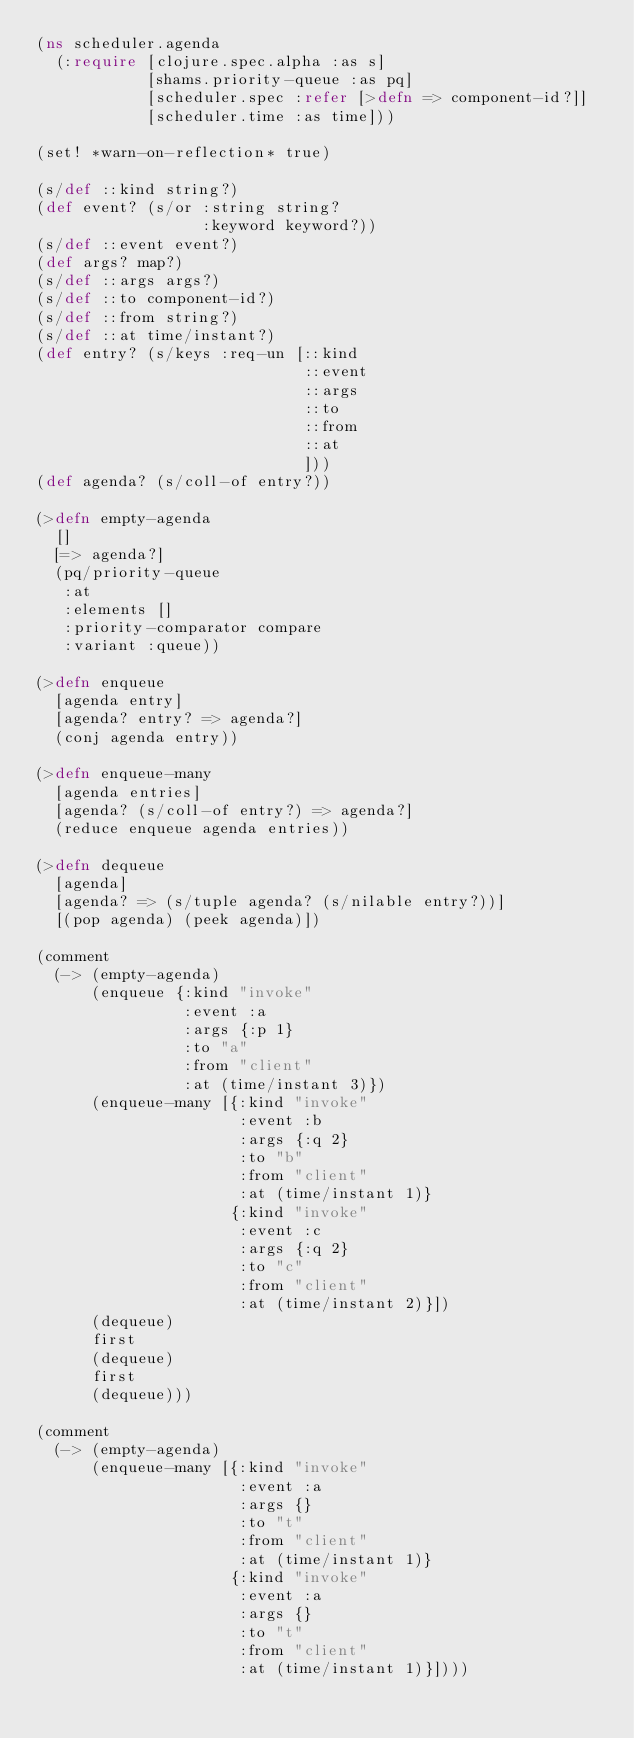Convert code to text. <code><loc_0><loc_0><loc_500><loc_500><_Clojure_>(ns scheduler.agenda
  (:require [clojure.spec.alpha :as s]
            [shams.priority-queue :as pq]
            [scheduler.spec :refer [>defn => component-id?]]
            [scheduler.time :as time]))

(set! *warn-on-reflection* true)

(s/def ::kind string?)
(def event? (s/or :string string?
                  :keyword keyword?))
(s/def ::event event?)
(def args? map?)
(s/def ::args args?)
(s/def ::to component-id?)
(s/def ::from string?)
(s/def ::at time/instant?)
(def entry? (s/keys :req-un [::kind
                             ::event
                             ::args
                             ::to
                             ::from
                             ::at
                             ]))
(def agenda? (s/coll-of entry?))

(>defn empty-agenda
  []
  [=> agenda?]
  (pq/priority-queue
   :at
   :elements []
   :priority-comparator compare
   :variant :queue))

(>defn enqueue
  [agenda entry]
  [agenda? entry? => agenda?]
  (conj agenda entry))

(>defn enqueue-many
  [agenda entries]
  [agenda? (s/coll-of entry?) => agenda?]
  (reduce enqueue agenda entries))

(>defn dequeue
  [agenda]
  [agenda? => (s/tuple agenda? (s/nilable entry?))]
  [(pop agenda) (peek agenda)])

(comment
  (-> (empty-agenda)
      (enqueue {:kind "invoke"
                :event :a
                :args {:p 1}
                :to "a"
                :from "client"
                :at (time/instant 3)})
      (enqueue-many [{:kind "invoke"
                      :event :b
                      :args {:q 2}
                      :to "b"
                      :from "client"
                      :at (time/instant 1)}
                     {:kind "invoke"
                      :event :c
                      :args {:q 2}
                      :to "c"
                      :from "client"
                      :at (time/instant 2)}])
      (dequeue)
      first
      (dequeue)
      first
      (dequeue)))

(comment
  (-> (empty-agenda)
      (enqueue-many [{:kind "invoke"
                      :event :a
                      :args {}
                      :to "t"
                      :from "client"
                      :at (time/instant 1)}
                     {:kind "invoke"
                      :event :a
                      :args {}
                      :to "t"
                      :from "client"
                      :at (time/instant 1)}])))
</code> 